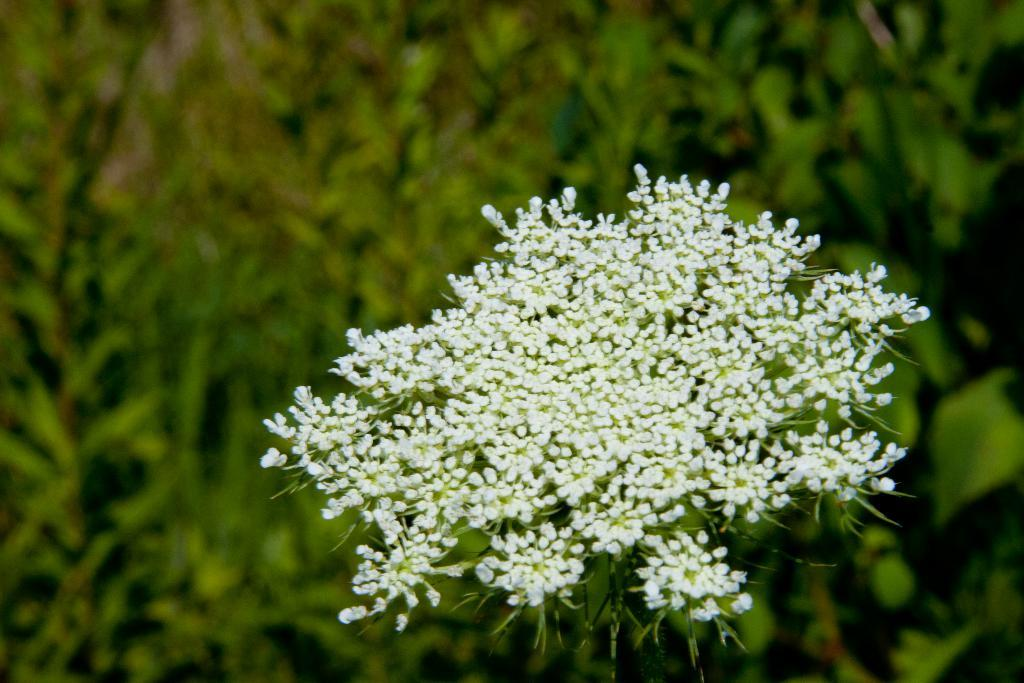What type of plant is the main subject of the image? There is a cow parsley plant in the image. How is the background of the image depicted? The background of the image is blurred. What else can be seen in the background besides the blurred area? There are other plants visible in the background. What type of fuel is being used by the cow parsley plant in the image? Cow parsley plants do not use fuel; they are living organisms that obtain energy through photosynthesis. 